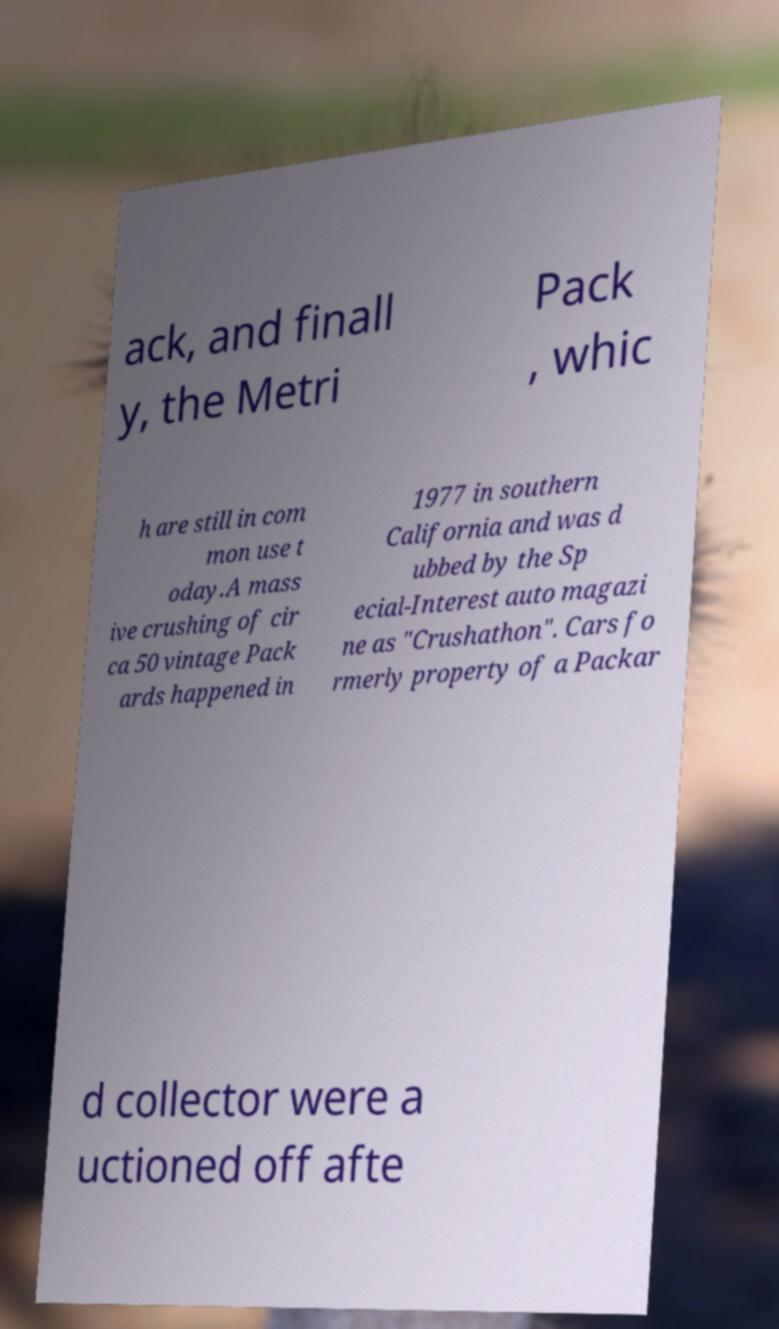I need the written content from this picture converted into text. Can you do that? ack, and finall y, the Metri Pack , whic h are still in com mon use t oday.A mass ive crushing of cir ca 50 vintage Pack ards happened in 1977 in southern California and was d ubbed by the Sp ecial-Interest auto magazi ne as "Crushathon". Cars fo rmerly property of a Packar d collector were a uctioned off afte 